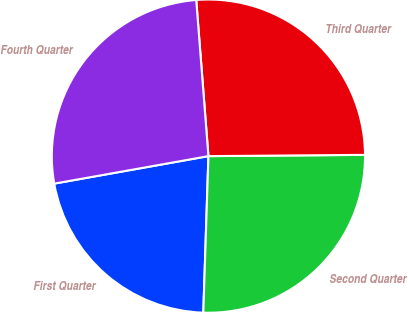<chart> <loc_0><loc_0><loc_500><loc_500><pie_chart><fcel>First Quarter<fcel>Second Quarter<fcel>Third Quarter<fcel>Fourth Quarter<nl><fcel>21.67%<fcel>25.65%<fcel>26.11%<fcel>26.57%<nl></chart> 